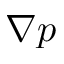<formula> <loc_0><loc_0><loc_500><loc_500>\nabla p</formula> 